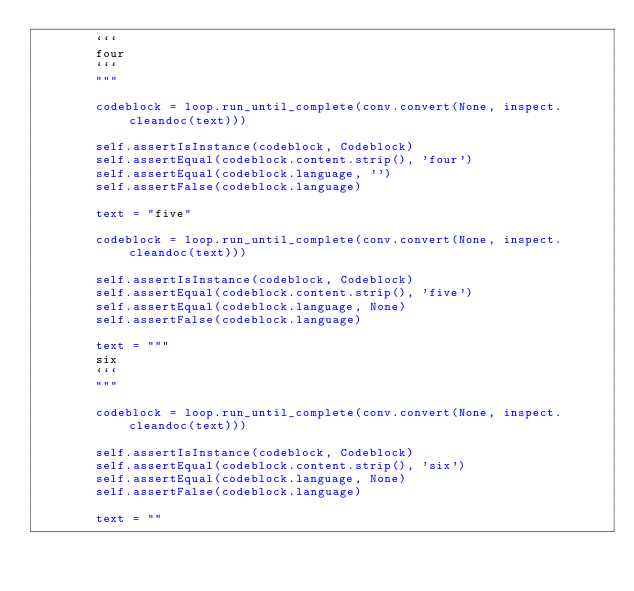<code> <loc_0><loc_0><loc_500><loc_500><_Python_>        ```
        four
        ```
        """

        codeblock = loop.run_until_complete(conv.convert(None, inspect.cleandoc(text)))

        self.assertIsInstance(codeblock, Codeblock)
        self.assertEqual(codeblock.content.strip(), 'four')
        self.assertEqual(codeblock.language, '')
        self.assertFalse(codeblock.language)

        text = "five"

        codeblock = loop.run_until_complete(conv.convert(None, inspect.cleandoc(text)))

        self.assertIsInstance(codeblock, Codeblock)
        self.assertEqual(codeblock.content.strip(), 'five')
        self.assertEqual(codeblock.language, None)
        self.assertFalse(codeblock.language)

        text = """
        six
        ```
        """

        codeblock = loop.run_until_complete(conv.convert(None, inspect.cleandoc(text)))

        self.assertIsInstance(codeblock, Codeblock)
        self.assertEqual(codeblock.content.strip(), 'six')
        self.assertEqual(codeblock.language, None)
        self.assertFalse(codeblock.language)

        text = ""
</code> 